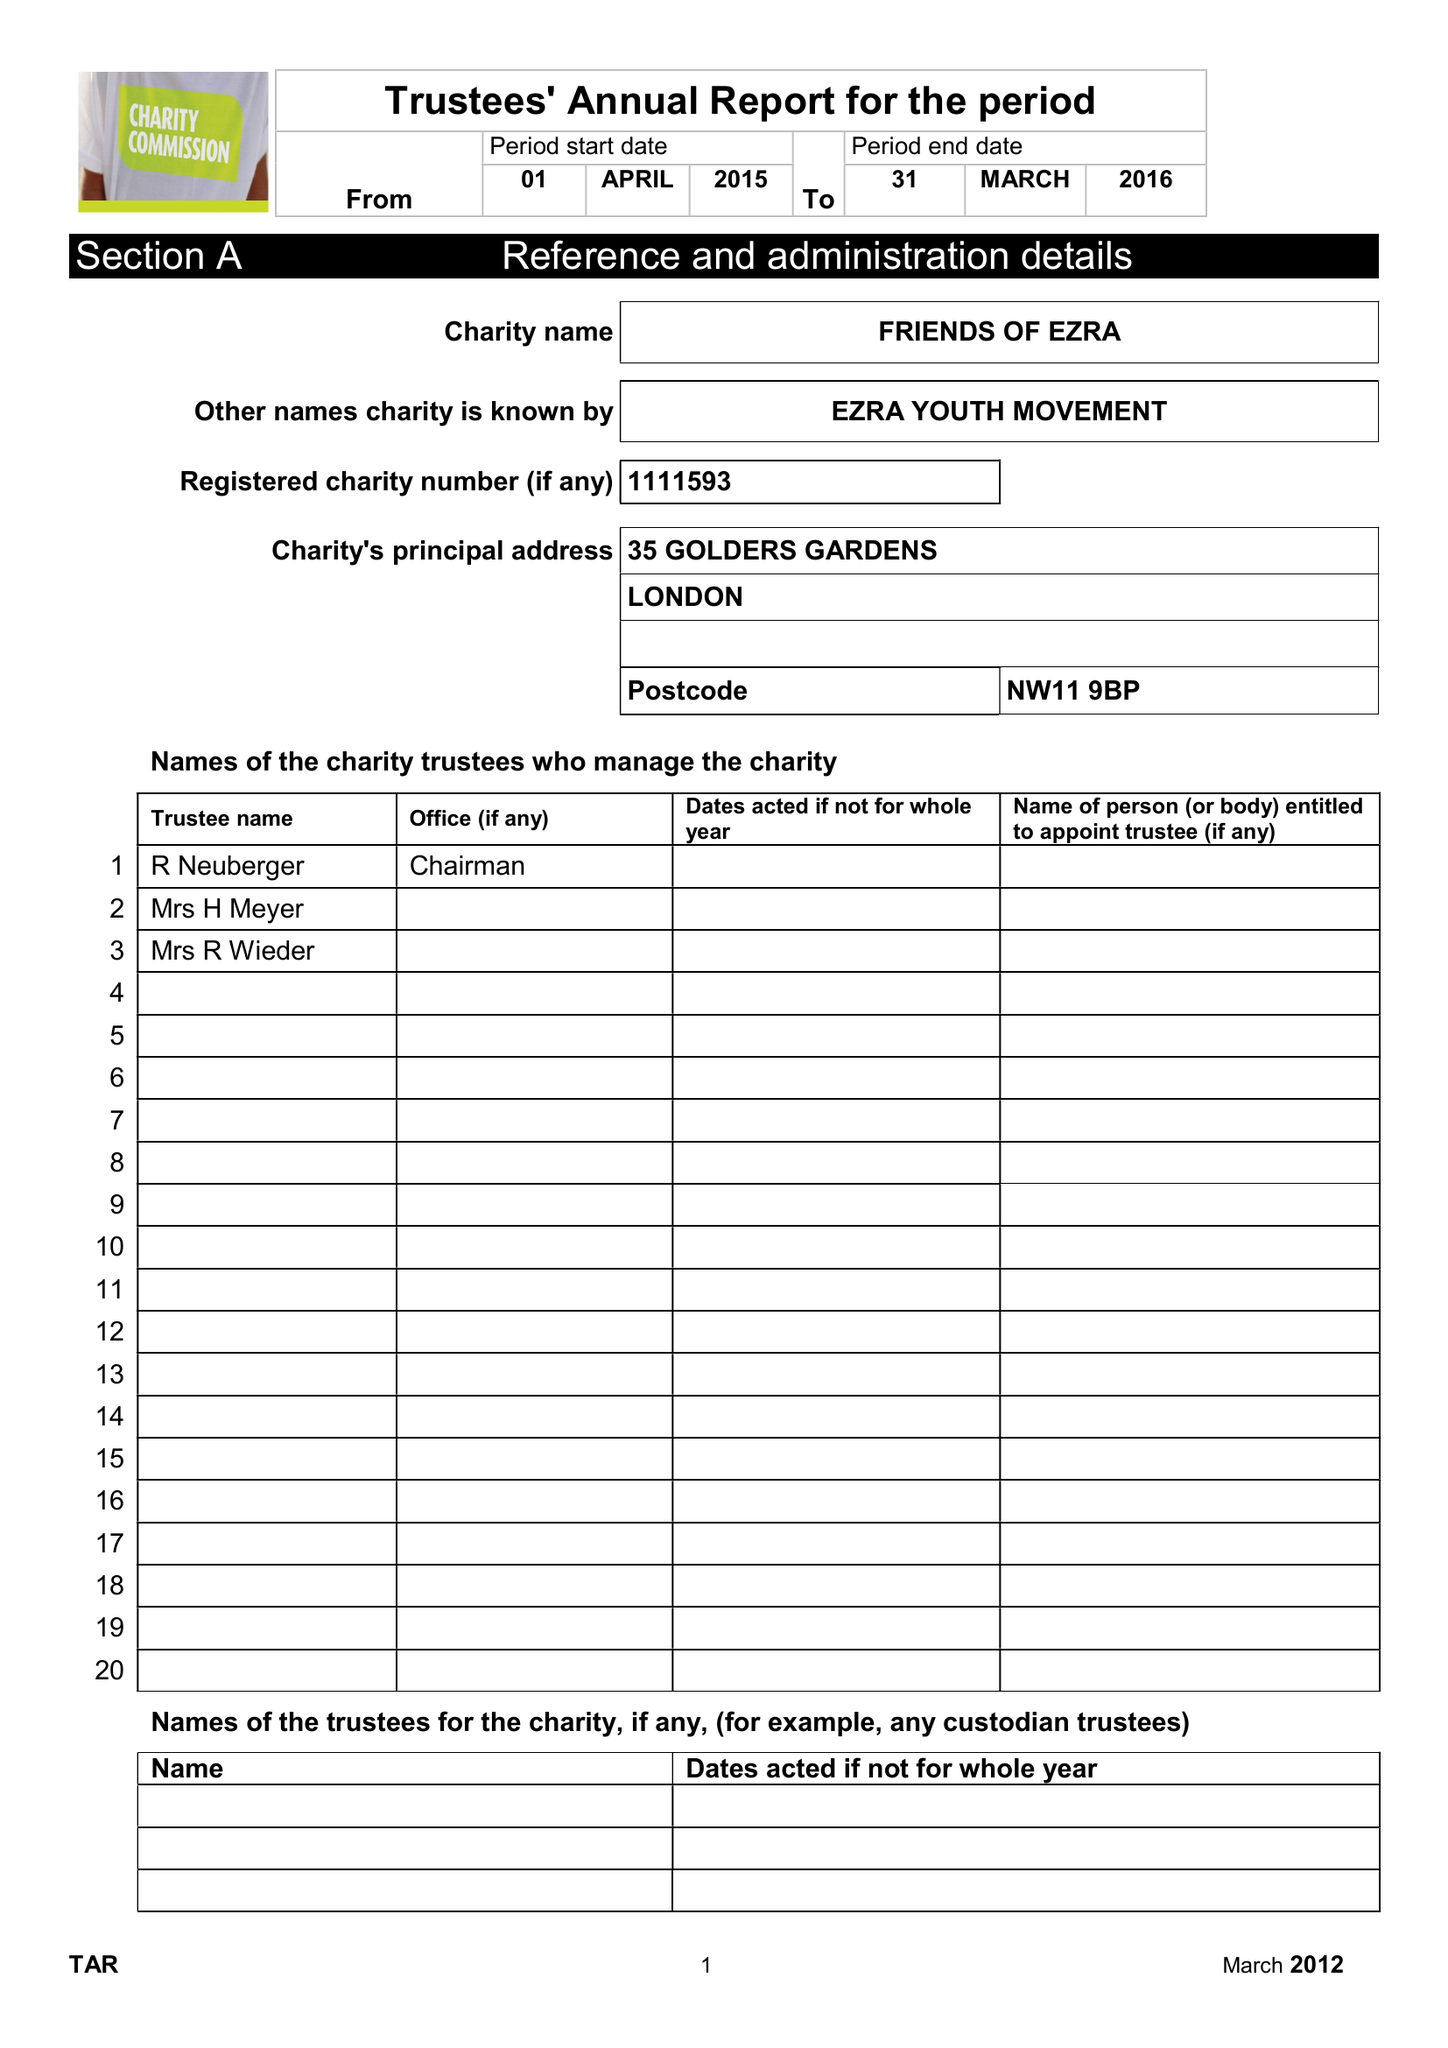What is the value for the income_annually_in_british_pounds?
Answer the question using a single word or phrase. 332696.00 